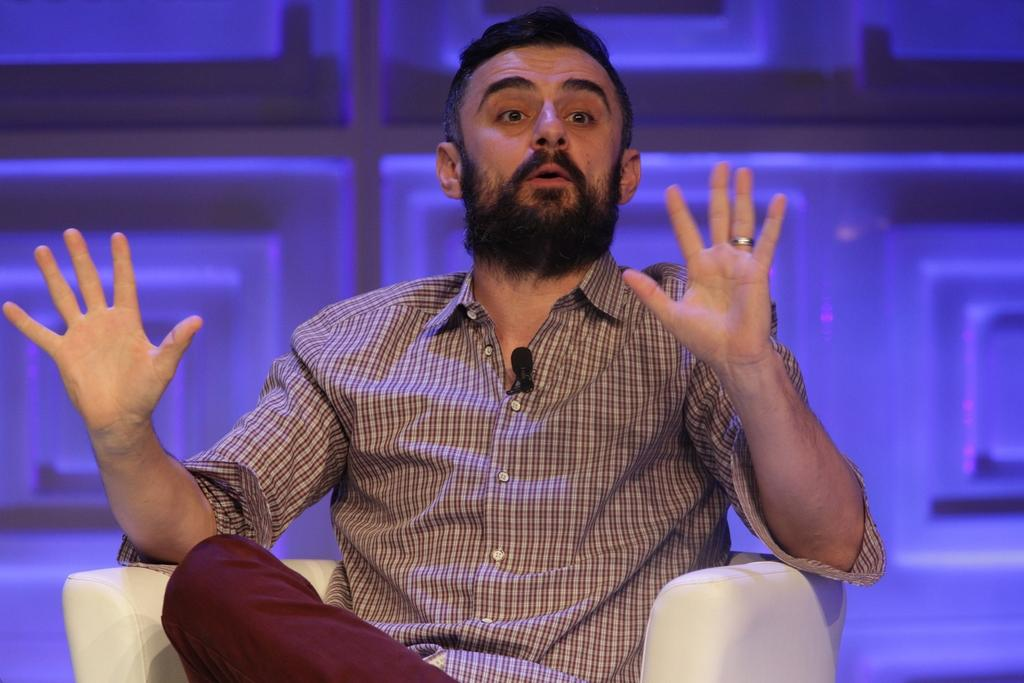Who is the main subject in the image? There is a man in the center of the image. Can you describe the man's facial hair? The man has a beard and a mustache. What is the man wearing in the image? The man is wearing a shirt. Where is the man sitting in the image? The man is sitting on a white color couch. What can be seen in the background of the image? There are objects in the background of the image. What type of insurance policy is the man discussing with the cracker in the image? There is no cracker or insurance policy present in the image; it only features a man sitting on a couch. 